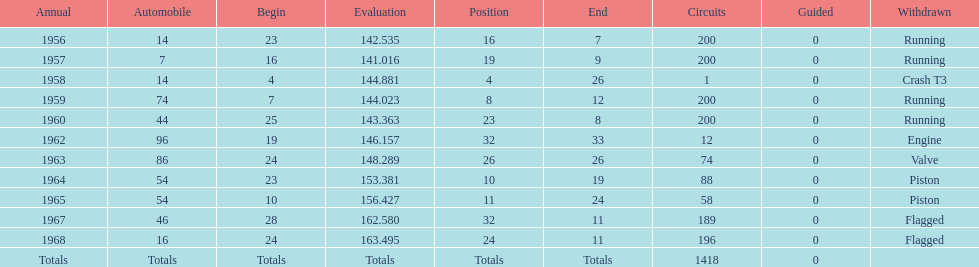Tell me the number of times he finished above 10th place. 3. Give me the full table as a dictionary. {'header': ['Annual', 'Automobile', 'Begin', 'Evaluation', 'Position', 'End', 'Circuits', 'Guided', 'Withdrawn'], 'rows': [['1956', '14', '23', '142.535', '16', '7', '200', '0', 'Running'], ['1957', '7', '16', '141.016', '19', '9', '200', '0', 'Running'], ['1958', '14', '4', '144.881', '4', '26', '1', '0', 'Crash T3'], ['1959', '74', '7', '144.023', '8', '12', '200', '0', 'Running'], ['1960', '44', '25', '143.363', '23', '8', '200', '0', 'Running'], ['1962', '96', '19', '146.157', '32', '33', '12', '0', 'Engine'], ['1963', '86', '24', '148.289', '26', '26', '74', '0', 'Valve'], ['1964', '54', '23', '153.381', '10', '19', '88', '0', 'Piston'], ['1965', '54', '10', '156.427', '11', '24', '58', '0', 'Piston'], ['1967', '46', '28', '162.580', '32', '11', '189', '0', 'Flagged'], ['1968', '16', '24', '163.495', '24', '11', '196', '0', 'Flagged'], ['Totals', 'Totals', 'Totals', 'Totals', 'Totals', 'Totals', '1418', '0', '']]} 